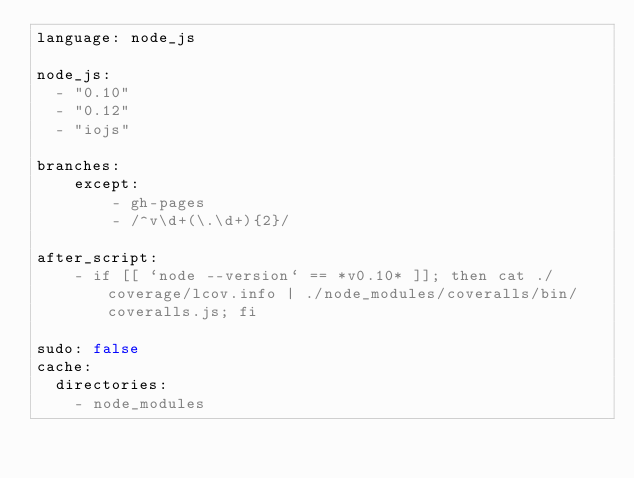<code> <loc_0><loc_0><loc_500><loc_500><_YAML_>language: node_js

node_js:
  - "0.10"
  - "0.12"
  - "iojs"

branches:
    except:
        - gh-pages
        - /^v\d+(\.\d+){2}/

after_script:
    - if [[ `node --version` == *v0.10* ]]; then cat ./coverage/lcov.info | ./node_modules/coveralls/bin/coveralls.js; fi

sudo: false
cache:
  directories:
    - node_modules
</code> 